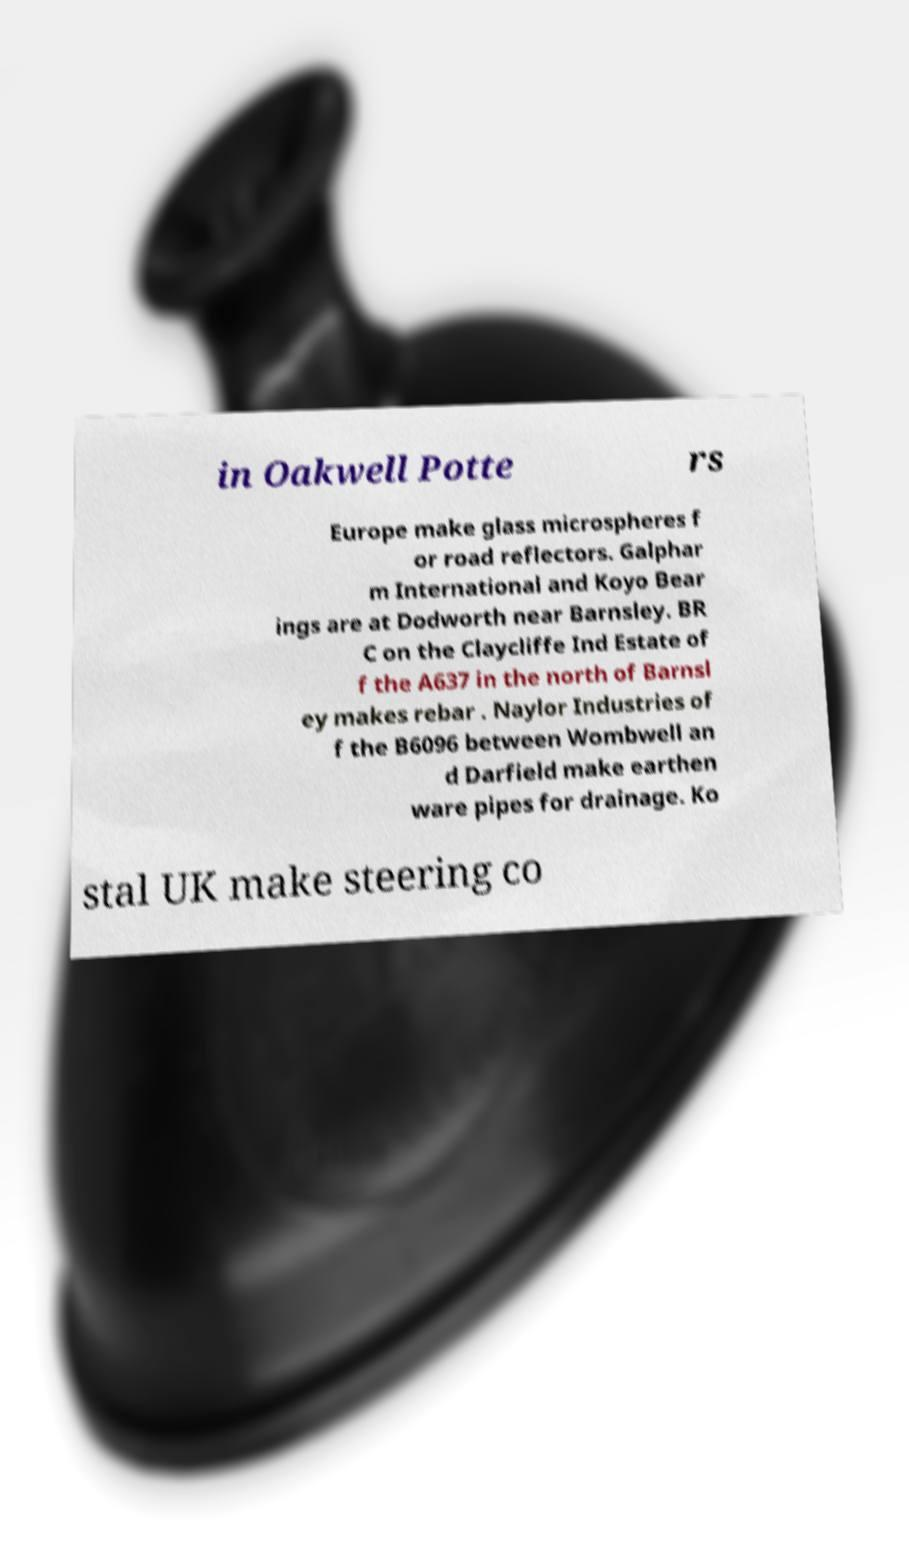Could you extract and type out the text from this image? in Oakwell Potte rs Europe make glass microspheres f or road reflectors. Galphar m International and Koyo Bear ings are at Dodworth near Barnsley. BR C on the Claycliffe Ind Estate of f the A637 in the north of Barnsl ey makes rebar . Naylor Industries of f the B6096 between Wombwell an d Darfield make earthen ware pipes for drainage. Ko stal UK make steering co 